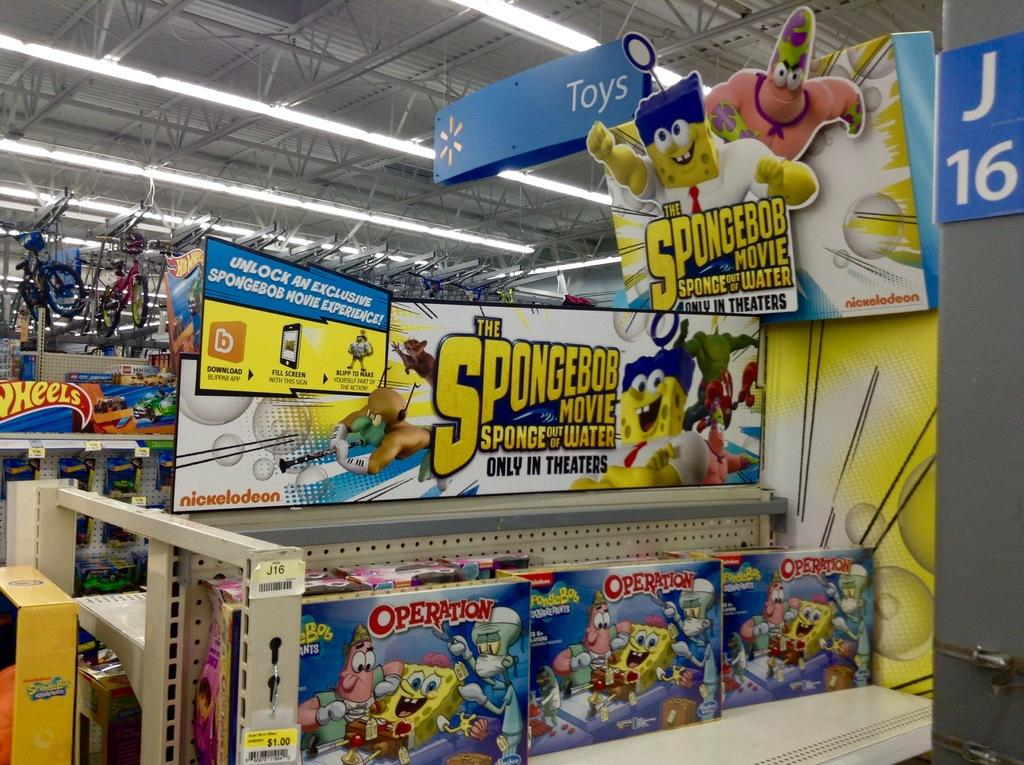<image>
Describe the image concisely. a store display featuring SpongeBob adverts and an Operation game toy on the shelf. 